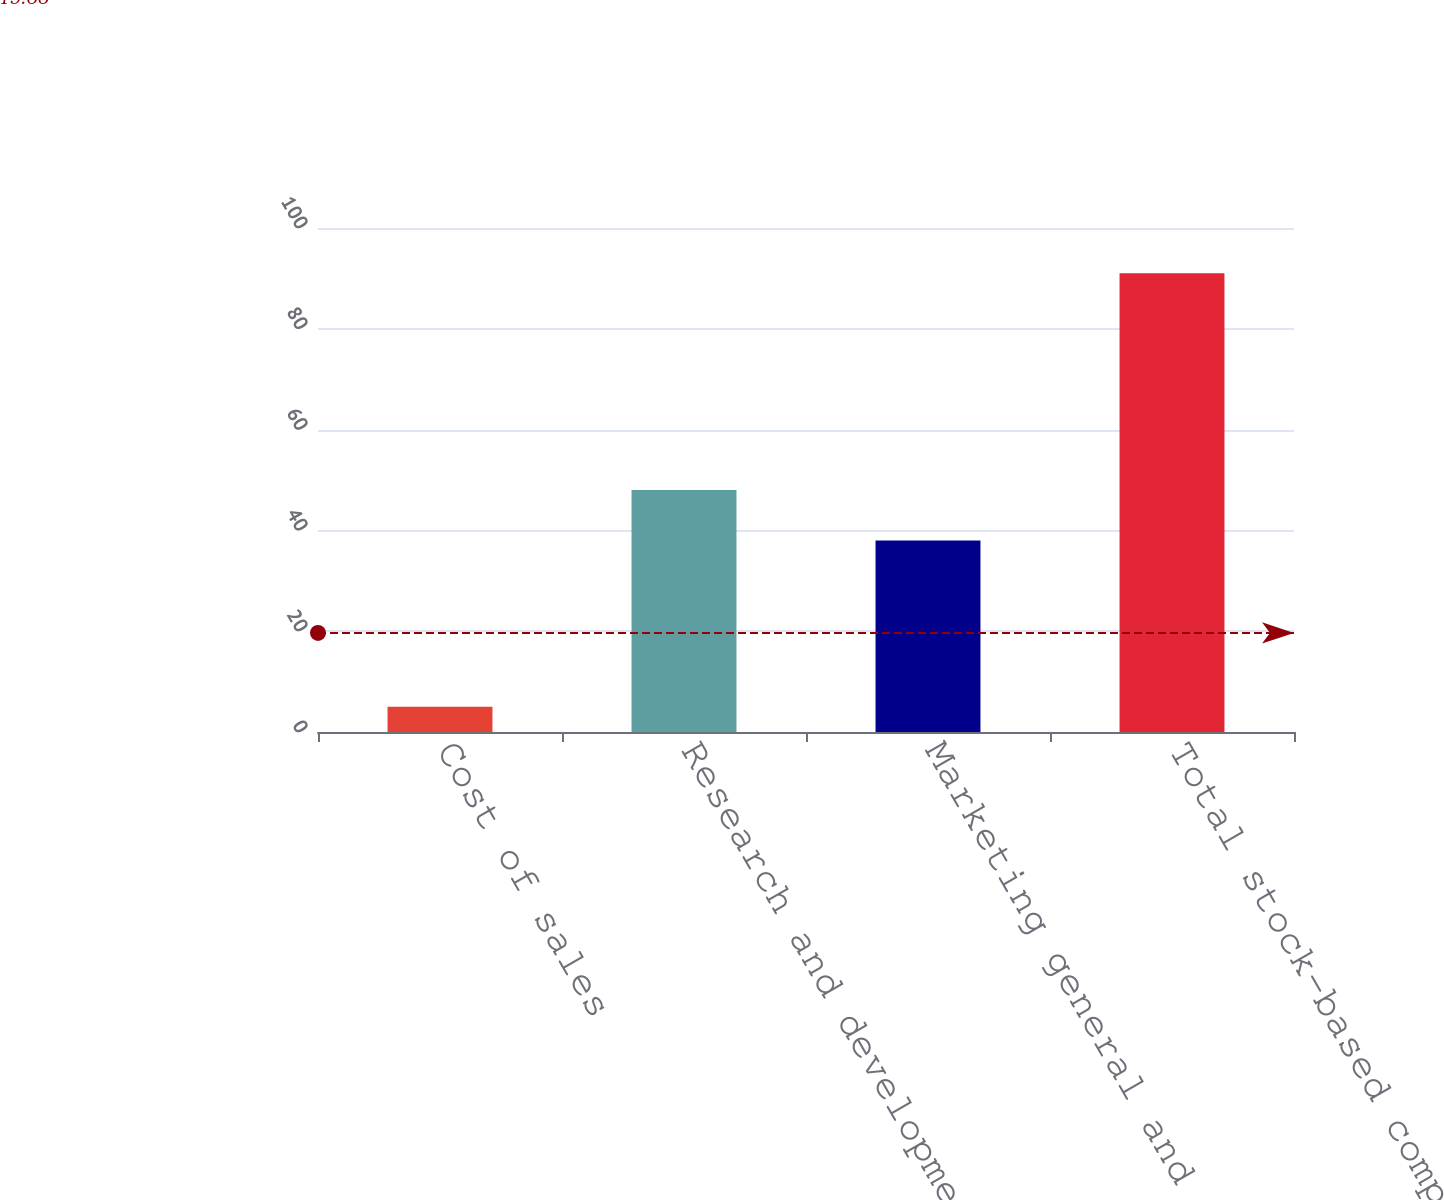Convert chart to OTSL. <chart><loc_0><loc_0><loc_500><loc_500><bar_chart><fcel>Cost of sales<fcel>Research and development<fcel>Marketing general and<fcel>Total stock-based compensation<nl><fcel>5<fcel>48<fcel>38<fcel>91<nl></chart> 